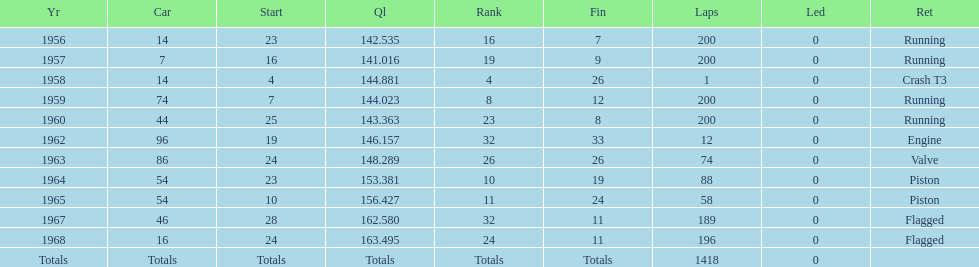Tell me the number of times he finished above 10th place. 3. 